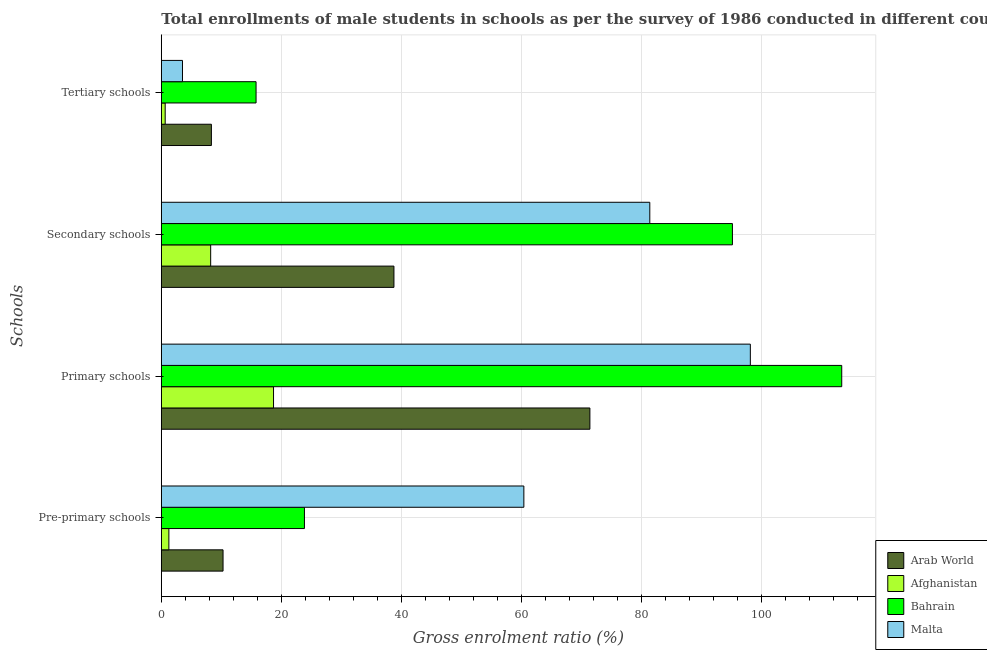How many groups of bars are there?
Make the answer very short. 4. How many bars are there on the 4th tick from the top?
Offer a terse response. 4. What is the label of the 3rd group of bars from the top?
Your response must be concise. Primary schools. What is the gross enrolment ratio(male) in pre-primary schools in Malta?
Make the answer very short. 60.41. Across all countries, what is the maximum gross enrolment ratio(male) in pre-primary schools?
Your answer should be compact. 60.41. Across all countries, what is the minimum gross enrolment ratio(male) in primary schools?
Give a very brief answer. 18.7. In which country was the gross enrolment ratio(male) in primary schools maximum?
Offer a very short reply. Bahrain. In which country was the gross enrolment ratio(male) in primary schools minimum?
Offer a very short reply. Afghanistan. What is the total gross enrolment ratio(male) in primary schools in the graph?
Your answer should be compact. 301.65. What is the difference between the gross enrolment ratio(male) in pre-primary schools in Bahrain and that in Afghanistan?
Your answer should be very brief. 22.59. What is the difference between the gross enrolment ratio(male) in primary schools in Afghanistan and the gross enrolment ratio(male) in secondary schools in Arab World?
Ensure brevity in your answer.  -20.07. What is the average gross enrolment ratio(male) in pre-primary schools per country?
Your answer should be very brief. 23.95. What is the difference between the gross enrolment ratio(male) in pre-primary schools and gross enrolment ratio(male) in primary schools in Malta?
Your answer should be very brief. -37.74. In how many countries, is the gross enrolment ratio(male) in secondary schools greater than 68 %?
Give a very brief answer. 2. What is the ratio of the gross enrolment ratio(male) in pre-primary schools in Bahrain to that in Afghanistan?
Your answer should be compact. 18.94. Is the difference between the gross enrolment ratio(male) in pre-primary schools in Malta and Arab World greater than the difference between the gross enrolment ratio(male) in secondary schools in Malta and Arab World?
Give a very brief answer. Yes. What is the difference between the highest and the second highest gross enrolment ratio(male) in secondary schools?
Your answer should be very brief. 13.77. What is the difference between the highest and the lowest gross enrolment ratio(male) in primary schools?
Offer a terse response. 94.68. In how many countries, is the gross enrolment ratio(male) in tertiary schools greater than the average gross enrolment ratio(male) in tertiary schools taken over all countries?
Provide a short and direct response. 2. Is the sum of the gross enrolment ratio(male) in pre-primary schools in Arab World and Afghanistan greater than the maximum gross enrolment ratio(male) in tertiary schools across all countries?
Keep it short and to the point. No. Is it the case that in every country, the sum of the gross enrolment ratio(male) in tertiary schools and gross enrolment ratio(male) in pre-primary schools is greater than the sum of gross enrolment ratio(male) in primary schools and gross enrolment ratio(male) in secondary schools?
Offer a very short reply. No. What does the 4th bar from the top in Primary schools represents?
Provide a short and direct response. Arab World. What does the 3rd bar from the bottom in Pre-primary schools represents?
Ensure brevity in your answer.  Bahrain. What is the difference between two consecutive major ticks on the X-axis?
Offer a terse response. 20. Where does the legend appear in the graph?
Offer a terse response. Bottom right. How are the legend labels stacked?
Your answer should be compact. Vertical. What is the title of the graph?
Ensure brevity in your answer.  Total enrollments of male students in schools as per the survey of 1986 conducted in different countries. Does "Equatorial Guinea" appear as one of the legend labels in the graph?
Provide a short and direct response. No. What is the label or title of the X-axis?
Give a very brief answer. Gross enrolment ratio (%). What is the label or title of the Y-axis?
Provide a succinct answer. Schools. What is the Gross enrolment ratio (%) of Arab World in Pre-primary schools?
Give a very brief answer. 10.29. What is the Gross enrolment ratio (%) of Afghanistan in Pre-primary schools?
Ensure brevity in your answer.  1.26. What is the Gross enrolment ratio (%) of Bahrain in Pre-primary schools?
Make the answer very short. 23.85. What is the Gross enrolment ratio (%) in Malta in Pre-primary schools?
Your answer should be compact. 60.41. What is the Gross enrolment ratio (%) of Arab World in Primary schools?
Your answer should be compact. 71.42. What is the Gross enrolment ratio (%) in Afghanistan in Primary schools?
Your answer should be compact. 18.7. What is the Gross enrolment ratio (%) of Bahrain in Primary schools?
Give a very brief answer. 113.38. What is the Gross enrolment ratio (%) of Malta in Primary schools?
Offer a terse response. 98.15. What is the Gross enrolment ratio (%) in Arab World in Secondary schools?
Keep it short and to the point. 38.76. What is the Gross enrolment ratio (%) in Afghanistan in Secondary schools?
Your answer should be very brief. 8.22. What is the Gross enrolment ratio (%) in Bahrain in Secondary schools?
Your answer should be compact. 95.17. What is the Gross enrolment ratio (%) of Malta in Secondary schools?
Offer a terse response. 81.4. What is the Gross enrolment ratio (%) in Arab World in Tertiary schools?
Give a very brief answer. 8.34. What is the Gross enrolment ratio (%) in Afghanistan in Tertiary schools?
Keep it short and to the point. 0.65. What is the Gross enrolment ratio (%) in Bahrain in Tertiary schools?
Provide a succinct answer. 15.79. What is the Gross enrolment ratio (%) of Malta in Tertiary schools?
Offer a very short reply. 3.53. Across all Schools, what is the maximum Gross enrolment ratio (%) of Arab World?
Offer a terse response. 71.42. Across all Schools, what is the maximum Gross enrolment ratio (%) in Afghanistan?
Your answer should be very brief. 18.7. Across all Schools, what is the maximum Gross enrolment ratio (%) in Bahrain?
Provide a short and direct response. 113.38. Across all Schools, what is the maximum Gross enrolment ratio (%) of Malta?
Keep it short and to the point. 98.15. Across all Schools, what is the minimum Gross enrolment ratio (%) of Arab World?
Provide a succinct answer. 8.34. Across all Schools, what is the minimum Gross enrolment ratio (%) of Afghanistan?
Offer a terse response. 0.65. Across all Schools, what is the minimum Gross enrolment ratio (%) in Bahrain?
Your answer should be very brief. 15.79. Across all Schools, what is the minimum Gross enrolment ratio (%) in Malta?
Provide a succinct answer. 3.53. What is the total Gross enrolment ratio (%) in Arab World in the graph?
Make the answer very short. 128.81. What is the total Gross enrolment ratio (%) of Afghanistan in the graph?
Your answer should be compact. 28.83. What is the total Gross enrolment ratio (%) of Bahrain in the graph?
Offer a very short reply. 248.19. What is the total Gross enrolment ratio (%) in Malta in the graph?
Make the answer very short. 243.49. What is the difference between the Gross enrolment ratio (%) in Arab World in Pre-primary schools and that in Primary schools?
Keep it short and to the point. -61.13. What is the difference between the Gross enrolment ratio (%) of Afghanistan in Pre-primary schools and that in Primary schools?
Ensure brevity in your answer.  -17.44. What is the difference between the Gross enrolment ratio (%) in Bahrain in Pre-primary schools and that in Primary schools?
Offer a terse response. -89.53. What is the difference between the Gross enrolment ratio (%) of Malta in Pre-primary schools and that in Primary schools?
Offer a terse response. -37.74. What is the difference between the Gross enrolment ratio (%) in Arab World in Pre-primary schools and that in Secondary schools?
Provide a short and direct response. -28.48. What is the difference between the Gross enrolment ratio (%) of Afghanistan in Pre-primary schools and that in Secondary schools?
Keep it short and to the point. -6.97. What is the difference between the Gross enrolment ratio (%) of Bahrain in Pre-primary schools and that in Secondary schools?
Provide a short and direct response. -71.32. What is the difference between the Gross enrolment ratio (%) in Malta in Pre-primary schools and that in Secondary schools?
Keep it short and to the point. -20.99. What is the difference between the Gross enrolment ratio (%) in Arab World in Pre-primary schools and that in Tertiary schools?
Your response must be concise. 1.94. What is the difference between the Gross enrolment ratio (%) in Afghanistan in Pre-primary schools and that in Tertiary schools?
Your response must be concise. 0.61. What is the difference between the Gross enrolment ratio (%) in Bahrain in Pre-primary schools and that in Tertiary schools?
Keep it short and to the point. 8.06. What is the difference between the Gross enrolment ratio (%) in Malta in Pre-primary schools and that in Tertiary schools?
Offer a terse response. 56.89. What is the difference between the Gross enrolment ratio (%) in Arab World in Primary schools and that in Secondary schools?
Offer a very short reply. 32.65. What is the difference between the Gross enrolment ratio (%) in Afghanistan in Primary schools and that in Secondary schools?
Give a very brief answer. 10.47. What is the difference between the Gross enrolment ratio (%) of Bahrain in Primary schools and that in Secondary schools?
Your answer should be compact. 18.21. What is the difference between the Gross enrolment ratio (%) in Malta in Primary schools and that in Secondary schools?
Offer a very short reply. 16.75. What is the difference between the Gross enrolment ratio (%) of Arab World in Primary schools and that in Tertiary schools?
Your answer should be compact. 63.07. What is the difference between the Gross enrolment ratio (%) in Afghanistan in Primary schools and that in Tertiary schools?
Your response must be concise. 18.05. What is the difference between the Gross enrolment ratio (%) of Bahrain in Primary schools and that in Tertiary schools?
Your answer should be compact. 97.59. What is the difference between the Gross enrolment ratio (%) in Malta in Primary schools and that in Tertiary schools?
Your answer should be very brief. 94.63. What is the difference between the Gross enrolment ratio (%) of Arab World in Secondary schools and that in Tertiary schools?
Make the answer very short. 30.42. What is the difference between the Gross enrolment ratio (%) of Afghanistan in Secondary schools and that in Tertiary schools?
Keep it short and to the point. 7.58. What is the difference between the Gross enrolment ratio (%) of Bahrain in Secondary schools and that in Tertiary schools?
Give a very brief answer. 79.38. What is the difference between the Gross enrolment ratio (%) of Malta in Secondary schools and that in Tertiary schools?
Offer a very short reply. 77.87. What is the difference between the Gross enrolment ratio (%) of Arab World in Pre-primary schools and the Gross enrolment ratio (%) of Afghanistan in Primary schools?
Provide a succinct answer. -8.41. What is the difference between the Gross enrolment ratio (%) in Arab World in Pre-primary schools and the Gross enrolment ratio (%) in Bahrain in Primary schools?
Your answer should be very brief. -103.1. What is the difference between the Gross enrolment ratio (%) of Arab World in Pre-primary schools and the Gross enrolment ratio (%) of Malta in Primary schools?
Your answer should be very brief. -87.87. What is the difference between the Gross enrolment ratio (%) in Afghanistan in Pre-primary schools and the Gross enrolment ratio (%) in Bahrain in Primary schools?
Give a very brief answer. -112.12. What is the difference between the Gross enrolment ratio (%) in Afghanistan in Pre-primary schools and the Gross enrolment ratio (%) in Malta in Primary schools?
Offer a very short reply. -96.89. What is the difference between the Gross enrolment ratio (%) in Bahrain in Pre-primary schools and the Gross enrolment ratio (%) in Malta in Primary schools?
Give a very brief answer. -74.3. What is the difference between the Gross enrolment ratio (%) of Arab World in Pre-primary schools and the Gross enrolment ratio (%) of Afghanistan in Secondary schools?
Offer a terse response. 2.06. What is the difference between the Gross enrolment ratio (%) in Arab World in Pre-primary schools and the Gross enrolment ratio (%) in Bahrain in Secondary schools?
Offer a terse response. -84.88. What is the difference between the Gross enrolment ratio (%) of Arab World in Pre-primary schools and the Gross enrolment ratio (%) of Malta in Secondary schools?
Your answer should be very brief. -71.11. What is the difference between the Gross enrolment ratio (%) of Afghanistan in Pre-primary schools and the Gross enrolment ratio (%) of Bahrain in Secondary schools?
Your answer should be compact. -93.91. What is the difference between the Gross enrolment ratio (%) of Afghanistan in Pre-primary schools and the Gross enrolment ratio (%) of Malta in Secondary schools?
Offer a terse response. -80.14. What is the difference between the Gross enrolment ratio (%) of Bahrain in Pre-primary schools and the Gross enrolment ratio (%) of Malta in Secondary schools?
Give a very brief answer. -57.55. What is the difference between the Gross enrolment ratio (%) of Arab World in Pre-primary schools and the Gross enrolment ratio (%) of Afghanistan in Tertiary schools?
Provide a succinct answer. 9.64. What is the difference between the Gross enrolment ratio (%) of Arab World in Pre-primary schools and the Gross enrolment ratio (%) of Bahrain in Tertiary schools?
Your response must be concise. -5.5. What is the difference between the Gross enrolment ratio (%) of Arab World in Pre-primary schools and the Gross enrolment ratio (%) of Malta in Tertiary schools?
Your response must be concise. 6.76. What is the difference between the Gross enrolment ratio (%) of Afghanistan in Pre-primary schools and the Gross enrolment ratio (%) of Bahrain in Tertiary schools?
Your response must be concise. -14.53. What is the difference between the Gross enrolment ratio (%) in Afghanistan in Pre-primary schools and the Gross enrolment ratio (%) in Malta in Tertiary schools?
Offer a very short reply. -2.27. What is the difference between the Gross enrolment ratio (%) in Bahrain in Pre-primary schools and the Gross enrolment ratio (%) in Malta in Tertiary schools?
Your response must be concise. 20.32. What is the difference between the Gross enrolment ratio (%) in Arab World in Primary schools and the Gross enrolment ratio (%) in Afghanistan in Secondary schools?
Keep it short and to the point. 63.19. What is the difference between the Gross enrolment ratio (%) of Arab World in Primary schools and the Gross enrolment ratio (%) of Bahrain in Secondary schools?
Keep it short and to the point. -23.75. What is the difference between the Gross enrolment ratio (%) of Arab World in Primary schools and the Gross enrolment ratio (%) of Malta in Secondary schools?
Offer a very short reply. -9.98. What is the difference between the Gross enrolment ratio (%) of Afghanistan in Primary schools and the Gross enrolment ratio (%) of Bahrain in Secondary schools?
Your answer should be compact. -76.47. What is the difference between the Gross enrolment ratio (%) in Afghanistan in Primary schools and the Gross enrolment ratio (%) in Malta in Secondary schools?
Your answer should be very brief. -62.7. What is the difference between the Gross enrolment ratio (%) of Bahrain in Primary schools and the Gross enrolment ratio (%) of Malta in Secondary schools?
Offer a terse response. 31.98. What is the difference between the Gross enrolment ratio (%) of Arab World in Primary schools and the Gross enrolment ratio (%) of Afghanistan in Tertiary schools?
Your response must be concise. 70.77. What is the difference between the Gross enrolment ratio (%) of Arab World in Primary schools and the Gross enrolment ratio (%) of Bahrain in Tertiary schools?
Your response must be concise. 55.63. What is the difference between the Gross enrolment ratio (%) of Arab World in Primary schools and the Gross enrolment ratio (%) of Malta in Tertiary schools?
Your response must be concise. 67.89. What is the difference between the Gross enrolment ratio (%) in Afghanistan in Primary schools and the Gross enrolment ratio (%) in Bahrain in Tertiary schools?
Offer a terse response. 2.91. What is the difference between the Gross enrolment ratio (%) in Afghanistan in Primary schools and the Gross enrolment ratio (%) in Malta in Tertiary schools?
Your answer should be very brief. 15.17. What is the difference between the Gross enrolment ratio (%) of Bahrain in Primary schools and the Gross enrolment ratio (%) of Malta in Tertiary schools?
Keep it short and to the point. 109.86. What is the difference between the Gross enrolment ratio (%) in Arab World in Secondary schools and the Gross enrolment ratio (%) in Afghanistan in Tertiary schools?
Provide a succinct answer. 38.12. What is the difference between the Gross enrolment ratio (%) of Arab World in Secondary schools and the Gross enrolment ratio (%) of Bahrain in Tertiary schools?
Your answer should be very brief. 22.98. What is the difference between the Gross enrolment ratio (%) in Arab World in Secondary schools and the Gross enrolment ratio (%) in Malta in Tertiary schools?
Your answer should be very brief. 35.24. What is the difference between the Gross enrolment ratio (%) in Afghanistan in Secondary schools and the Gross enrolment ratio (%) in Bahrain in Tertiary schools?
Your answer should be compact. -7.56. What is the difference between the Gross enrolment ratio (%) of Afghanistan in Secondary schools and the Gross enrolment ratio (%) of Malta in Tertiary schools?
Your response must be concise. 4.7. What is the difference between the Gross enrolment ratio (%) of Bahrain in Secondary schools and the Gross enrolment ratio (%) of Malta in Tertiary schools?
Ensure brevity in your answer.  91.64. What is the average Gross enrolment ratio (%) of Arab World per Schools?
Your response must be concise. 32.2. What is the average Gross enrolment ratio (%) in Afghanistan per Schools?
Make the answer very short. 7.21. What is the average Gross enrolment ratio (%) of Bahrain per Schools?
Offer a terse response. 62.05. What is the average Gross enrolment ratio (%) of Malta per Schools?
Provide a succinct answer. 60.87. What is the difference between the Gross enrolment ratio (%) of Arab World and Gross enrolment ratio (%) of Afghanistan in Pre-primary schools?
Make the answer very short. 9.03. What is the difference between the Gross enrolment ratio (%) in Arab World and Gross enrolment ratio (%) in Bahrain in Pre-primary schools?
Your answer should be very brief. -13.56. What is the difference between the Gross enrolment ratio (%) of Arab World and Gross enrolment ratio (%) of Malta in Pre-primary schools?
Offer a terse response. -50.13. What is the difference between the Gross enrolment ratio (%) in Afghanistan and Gross enrolment ratio (%) in Bahrain in Pre-primary schools?
Make the answer very short. -22.59. What is the difference between the Gross enrolment ratio (%) of Afghanistan and Gross enrolment ratio (%) of Malta in Pre-primary schools?
Provide a succinct answer. -59.15. What is the difference between the Gross enrolment ratio (%) in Bahrain and Gross enrolment ratio (%) in Malta in Pre-primary schools?
Offer a terse response. -36.56. What is the difference between the Gross enrolment ratio (%) of Arab World and Gross enrolment ratio (%) of Afghanistan in Primary schools?
Provide a short and direct response. 52.72. What is the difference between the Gross enrolment ratio (%) of Arab World and Gross enrolment ratio (%) of Bahrain in Primary schools?
Your answer should be very brief. -41.97. What is the difference between the Gross enrolment ratio (%) of Arab World and Gross enrolment ratio (%) of Malta in Primary schools?
Keep it short and to the point. -26.74. What is the difference between the Gross enrolment ratio (%) in Afghanistan and Gross enrolment ratio (%) in Bahrain in Primary schools?
Keep it short and to the point. -94.68. What is the difference between the Gross enrolment ratio (%) in Afghanistan and Gross enrolment ratio (%) in Malta in Primary schools?
Your answer should be compact. -79.45. What is the difference between the Gross enrolment ratio (%) of Bahrain and Gross enrolment ratio (%) of Malta in Primary schools?
Your answer should be very brief. 15.23. What is the difference between the Gross enrolment ratio (%) of Arab World and Gross enrolment ratio (%) of Afghanistan in Secondary schools?
Your answer should be very brief. 30.54. What is the difference between the Gross enrolment ratio (%) in Arab World and Gross enrolment ratio (%) in Bahrain in Secondary schools?
Keep it short and to the point. -56.4. What is the difference between the Gross enrolment ratio (%) of Arab World and Gross enrolment ratio (%) of Malta in Secondary schools?
Your answer should be very brief. -42.64. What is the difference between the Gross enrolment ratio (%) in Afghanistan and Gross enrolment ratio (%) in Bahrain in Secondary schools?
Your answer should be compact. -86.94. What is the difference between the Gross enrolment ratio (%) in Afghanistan and Gross enrolment ratio (%) in Malta in Secondary schools?
Your response must be concise. -73.17. What is the difference between the Gross enrolment ratio (%) of Bahrain and Gross enrolment ratio (%) of Malta in Secondary schools?
Keep it short and to the point. 13.77. What is the difference between the Gross enrolment ratio (%) in Arab World and Gross enrolment ratio (%) in Afghanistan in Tertiary schools?
Offer a very short reply. 7.7. What is the difference between the Gross enrolment ratio (%) of Arab World and Gross enrolment ratio (%) of Bahrain in Tertiary schools?
Offer a terse response. -7.44. What is the difference between the Gross enrolment ratio (%) of Arab World and Gross enrolment ratio (%) of Malta in Tertiary schools?
Your response must be concise. 4.82. What is the difference between the Gross enrolment ratio (%) of Afghanistan and Gross enrolment ratio (%) of Bahrain in Tertiary schools?
Your response must be concise. -15.14. What is the difference between the Gross enrolment ratio (%) in Afghanistan and Gross enrolment ratio (%) in Malta in Tertiary schools?
Offer a very short reply. -2.88. What is the difference between the Gross enrolment ratio (%) of Bahrain and Gross enrolment ratio (%) of Malta in Tertiary schools?
Give a very brief answer. 12.26. What is the ratio of the Gross enrolment ratio (%) of Arab World in Pre-primary schools to that in Primary schools?
Your response must be concise. 0.14. What is the ratio of the Gross enrolment ratio (%) in Afghanistan in Pre-primary schools to that in Primary schools?
Ensure brevity in your answer.  0.07. What is the ratio of the Gross enrolment ratio (%) of Bahrain in Pre-primary schools to that in Primary schools?
Offer a terse response. 0.21. What is the ratio of the Gross enrolment ratio (%) of Malta in Pre-primary schools to that in Primary schools?
Your response must be concise. 0.62. What is the ratio of the Gross enrolment ratio (%) of Arab World in Pre-primary schools to that in Secondary schools?
Your answer should be compact. 0.27. What is the ratio of the Gross enrolment ratio (%) of Afghanistan in Pre-primary schools to that in Secondary schools?
Your answer should be compact. 0.15. What is the ratio of the Gross enrolment ratio (%) of Bahrain in Pre-primary schools to that in Secondary schools?
Offer a terse response. 0.25. What is the ratio of the Gross enrolment ratio (%) in Malta in Pre-primary schools to that in Secondary schools?
Provide a short and direct response. 0.74. What is the ratio of the Gross enrolment ratio (%) in Arab World in Pre-primary schools to that in Tertiary schools?
Ensure brevity in your answer.  1.23. What is the ratio of the Gross enrolment ratio (%) of Afghanistan in Pre-primary schools to that in Tertiary schools?
Your response must be concise. 1.95. What is the ratio of the Gross enrolment ratio (%) of Bahrain in Pre-primary schools to that in Tertiary schools?
Your answer should be very brief. 1.51. What is the ratio of the Gross enrolment ratio (%) of Malta in Pre-primary schools to that in Tertiary schools?
Ensure brevity in your answer.  17.13. What is the ratio of the Gross enrolment ratio (%) in Arab World in Primary schools to that in Secondary schools?
Give a very brief answer. 1.84. What is the ratio of the Gross enrolment ratio (%) in Afghanistan in Primary schools to that in Secondary schools?
Make the answer very short. 2.27. What is the ratio of the Gross enrolment ratio (%) of Bahrain in Primary schools to that in Secondary schools?
Provide a succinct answer. 1.19. What is the ratio of the Gross enrolment ratio (%) of Malta in Primary schools to that in Secondary schools?
Keep it short and to the point. 1.21. What is the ratio of the Gross enrolment ratio (%) of Arab World in Primary schools to that in Tertiary schools?
Make the answer very short. 8.56. What is the ratio of the Gross enrolment ratio (%) of Afghanistan in Primary schools to that in Tertiary schools?
Your response must be concise. 28.93. What is the ratio of the Gross enrolment ratio (%) in Bahrain in Primary schools to that in Tertiary schools?
Your answer should be very brief. 7.18. What is the ratio of the Gross enrolment ratio (%) in Malta in Primary schools to that in Tertiary schools?
Ensure brevity in your answer.  27.84. What is the ratio of the Gross enrolment ratio (%) in Arab World in Secondary schools to that in Tertiary schools?
Make the answer very short. 4.65. What is the ratio of the Gross enrolment ratio (%) in Afghanistan in Secondary schools to that in Tertiary schools?
Offer a terse response. 12.72. What is the ratio of the Gross enrolment ratio (%) of Bahrain in Secondary schools to that in Tertiary schools?
Provide a short and direct response. 6.03. What is the ratio of the Gross enrolment ratio (%) of Malta in Secondary schools to that in Tertiary schools?
Offer a very short reply. 23.08. What is the difference between the highest and the second highest Gross enrolment ratio (%) in Arab World?
Give a very brief answer. 32.65. What is the difference between the highest and the second highest Gross enrolment ratio (%) of Afghanistan?
Your response must be concise. 10.47. What is the difference between the highest and the second highest Gross enrolment ratio (%) in Bahrain?
Offer a terse response. 18.21. What is the difference between the highest and the second highest Gross enrolment ratio (%) in Malta?
Offer a terse response. 16.75. What is the difference between the highest and the lowest Gross enrolment ratio (%) of Arab World?
Provide a succinct answer. 63.07. What is the difference between the highest and the lowest Gross enrolment ratio (%) in Afghanistan?
Your answer should be compact. 18.05. What is the difference between the highest and the lowest Gross enrolment ratio (%) of Bahrain?
Provide a succinct answer. 97.59. What is the difference between the highest and the lowest Gross enrolment ratio (%) in Malta?
Your answer should be compact. 94.63. 